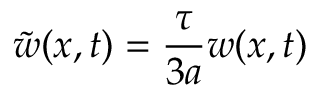<formula> <loc_0><loc_0><loc_500><loc_500>\tilde { w } ( x , t ) = \frac { \tau } { 3 a } w ( x , t )</formula> 